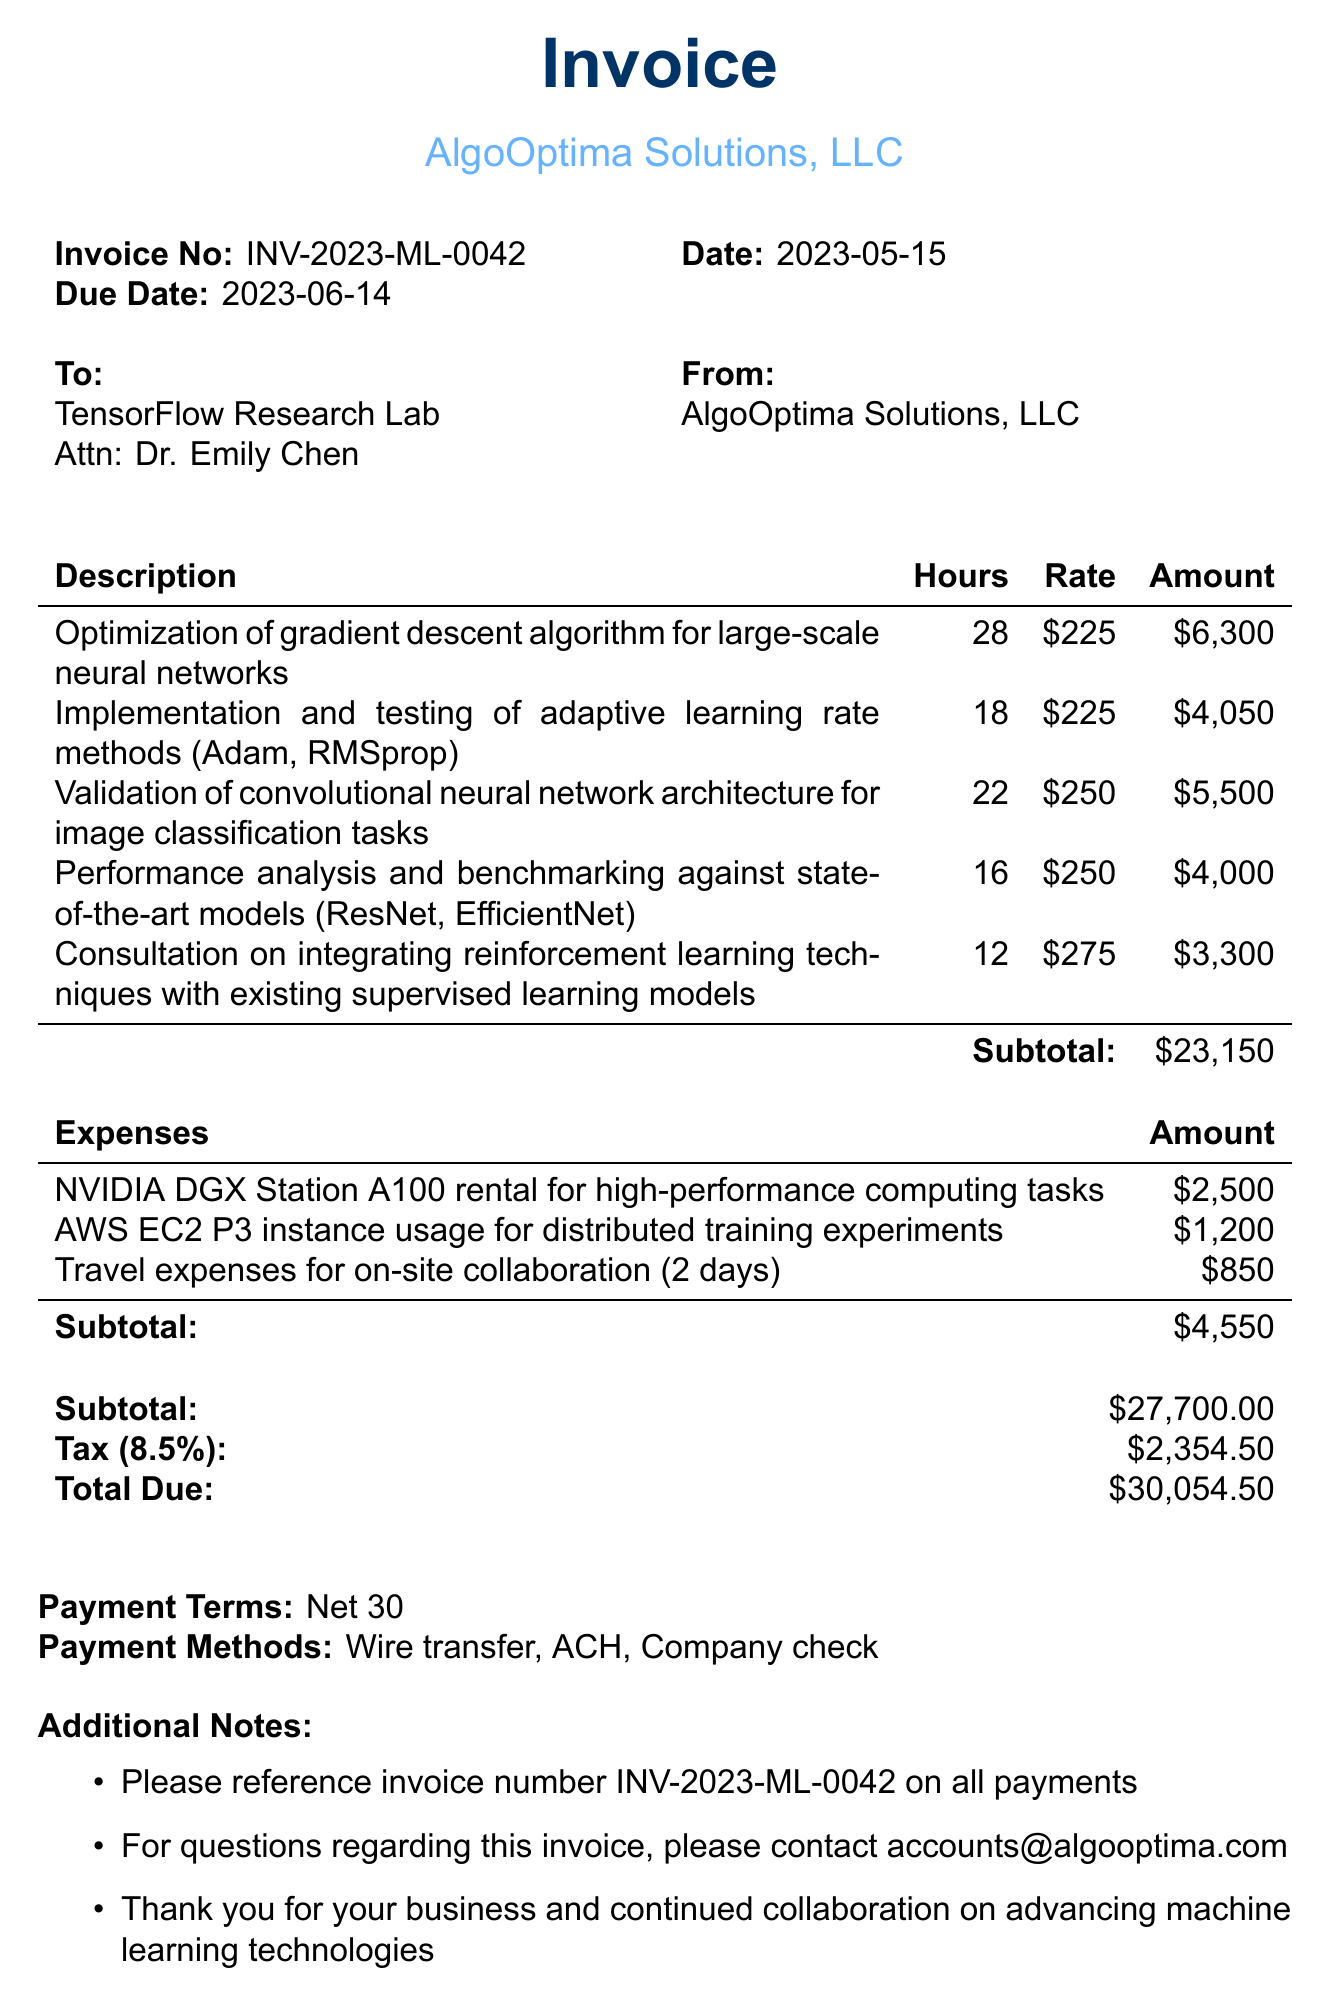What is the invoice number? The invoice number is specified in the document as a unique identifier.
Answer: INV-2023-ML-0042 What is the due date for the invoice? The due date is the date by which payment should be made.
Answer: 2023-06-14 Who is the consultant providing services? The consultant's name is mentioned at the top of the document.
Answer: AlgoOptima Solutions, LLC How many hours were spent on the optimization of gradient descent? This is specified as part of the services rendered in the document.
Answer: 28 What amount was charged for validating the CNN architecture? This amount is listed under the specific service category in the document.
Answer: $5500 What percentage is the tax rate applied to the subtotal? The tax rate is explicitly mentioned in the invoice details.
Answer: 8.5% What is the total amount due? The total due is calculated and presented at the end of the invoice.
Answer: $30054.50 What are the payment methods mentioned in the invoice? The document provides a list of acceptable payment methods.
Answer: Wire transfer, ACH, Company check Why is there a subtotal listed for both services and expenses? Subtotals are provided to clearly separate different billing components.
Answer: To clarify service and expense costs 